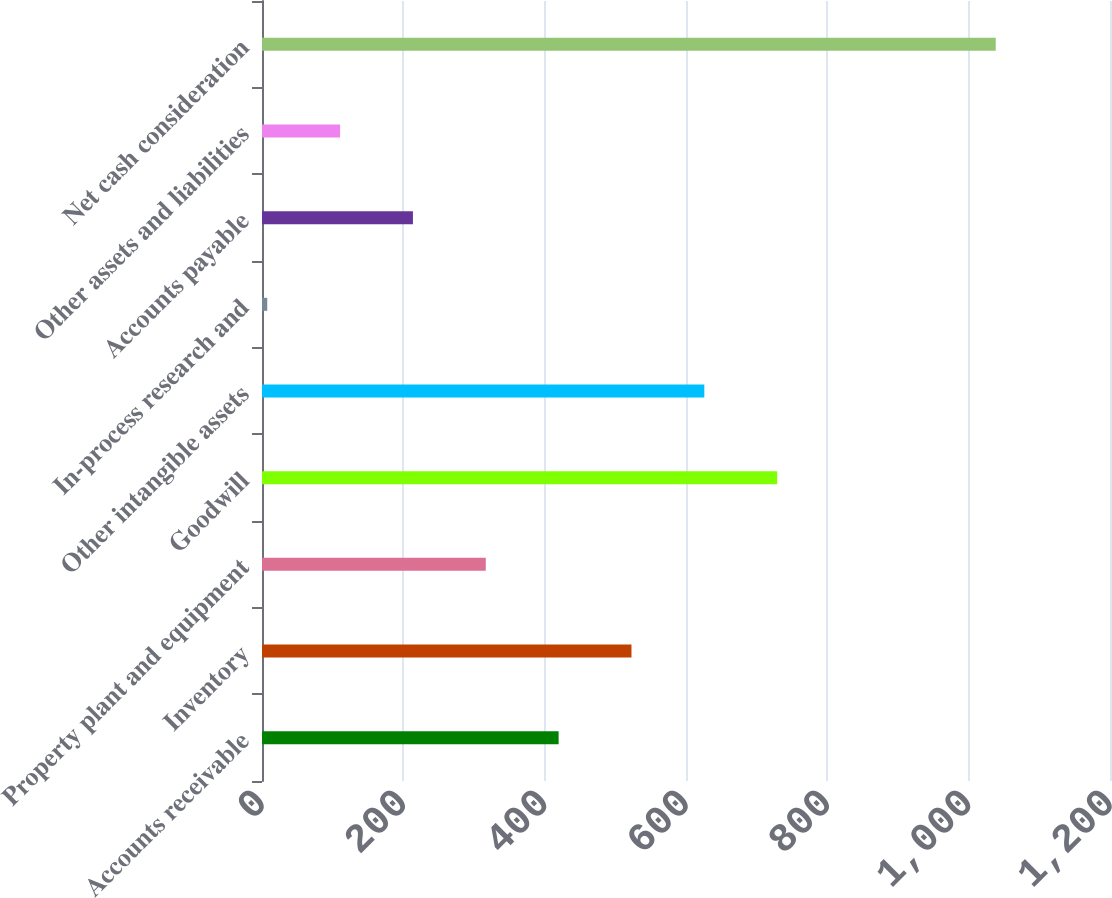Convert chart to OTSL. <chart><loc_0><loc_0><loc_500><loc_500><bar_chart><fcel>Accounts receivable<fcel>Inventory<fcel>Property plant and equipment<fcel>Goodwill<fcel>Other intangible assets<fcel>In-process research and<fcel>Accounts payable<fcel>Other assets and liabilities<fcel>Net cash consideration<nl><fcel>419.76<fcel>522.85<fcel>316.67<fcel>729.03<fcel>625.94<fcel>7.4<fcel>213.58<fcel>110.49<fcel>1038.3<nl></chart> 